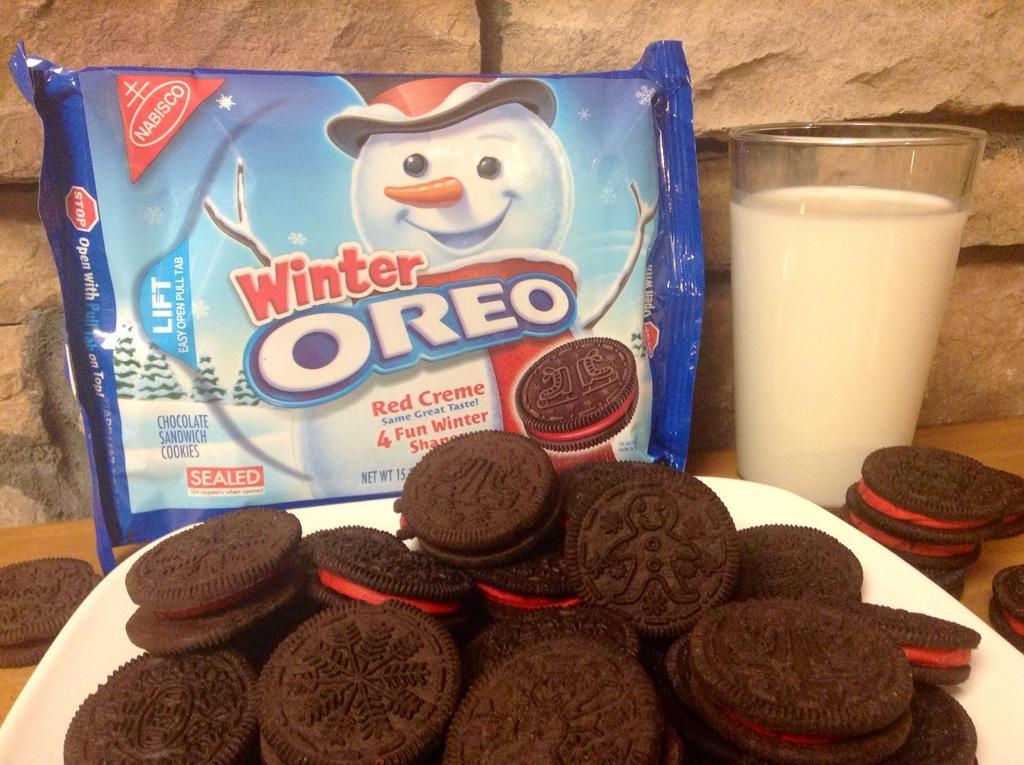Please provide a concise description of this image. In this picture I can see few cookies in the plate and I can see a glass of milk and a cookies packet and I can see few cookies on the table and I can see a stone wall in the back. 